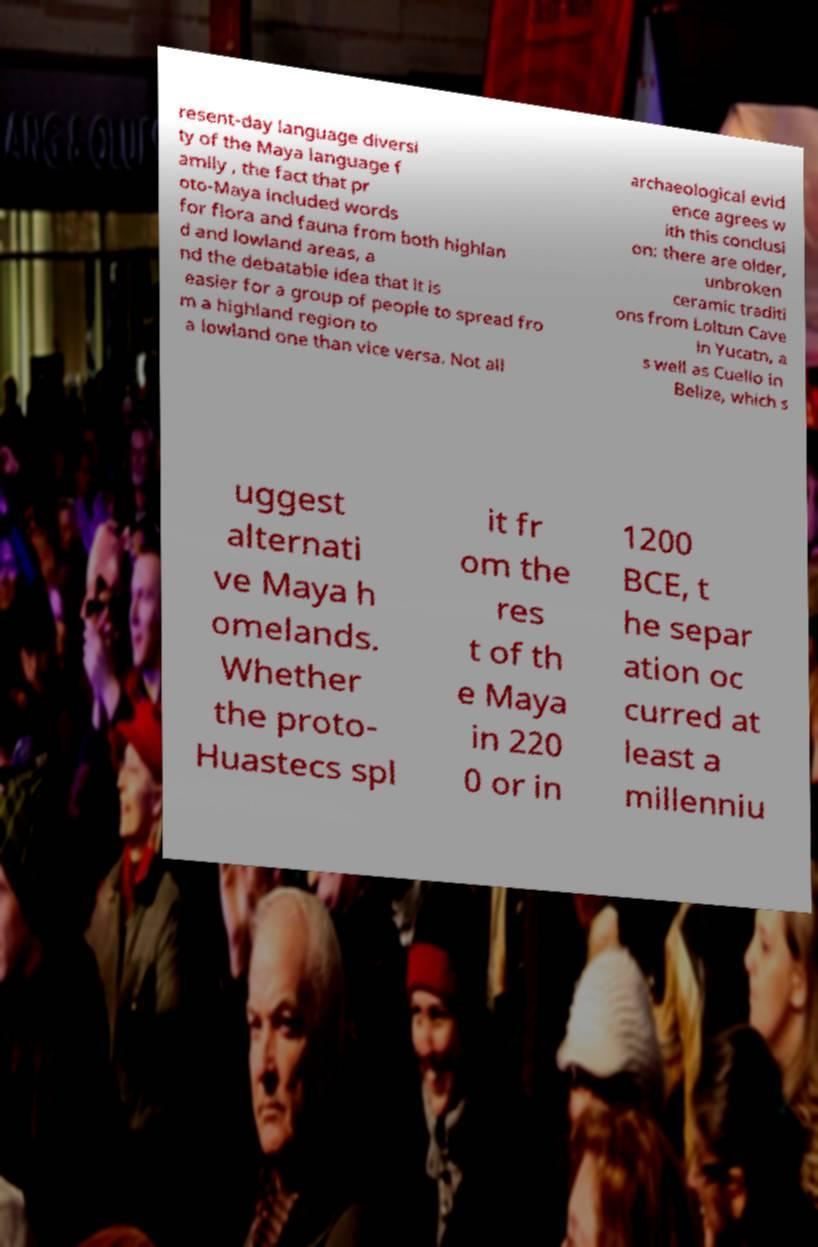For documentation purposes, I need the text within this image transcribed. Could you provide that? resent-day language diversi ty of the Maya language f amily , the fact that pr oto-Maya included words for flora and fauna from both highlan d and lowland areas, a nd the debatable idea that it is easier for a group of people to spread fro m a highland region to a lowland one than vice versa. Not all archaeological evid ence agrees w ith this conclusi on: there are older, unbroken ceramic traditi ons from Loltun Cave in Yucatn, a s well as Cuello in Belize, which s uggest alternati ve Maya h omelands. Whether the proto- Huastecs spl it fr om the res t of th e Maya in 220 0 or in 1200 BCE, t he separ ation oc curred at least a millenniu 